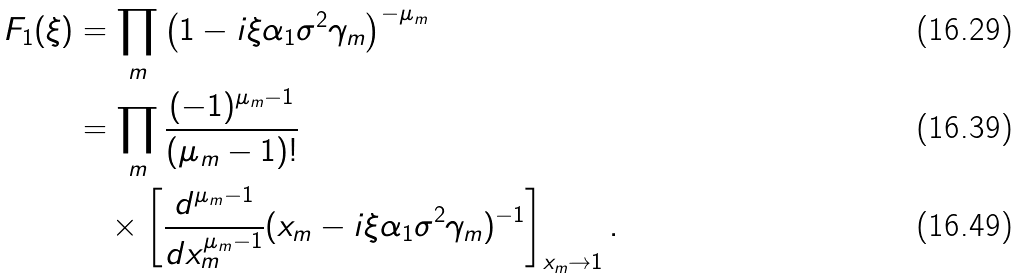<formula> <loc_0><loc_0><loc_500><loc_500>F _ { 1 } ( \xi ) & = \prod _ { m } \left ( 1 - i \xi \alpha _ { 1 } \sigma ^ { 2 } \gamma _ { m } \right ) ^ { - \mu _ { m } } \\ & = \prod _ { m } \frac { ( - 1 ) ^ { \mu _ { m } - 1 } } { ( \mu _ { m } - 1 ) ! } \\ & \quad \times \left [ \frac { d ^ { \mu _ { m } - 1 } } { d x _ { m } ^ { \mu _ { m } - 1 } } ( x _ { m } - i \xi \alpha _ { 1 } \sigma ^ { 2 } \gamma _ { m } ) ^ { - 1 } \right ] _ { x _ { m } \rightarrow 1 } .</formula> 